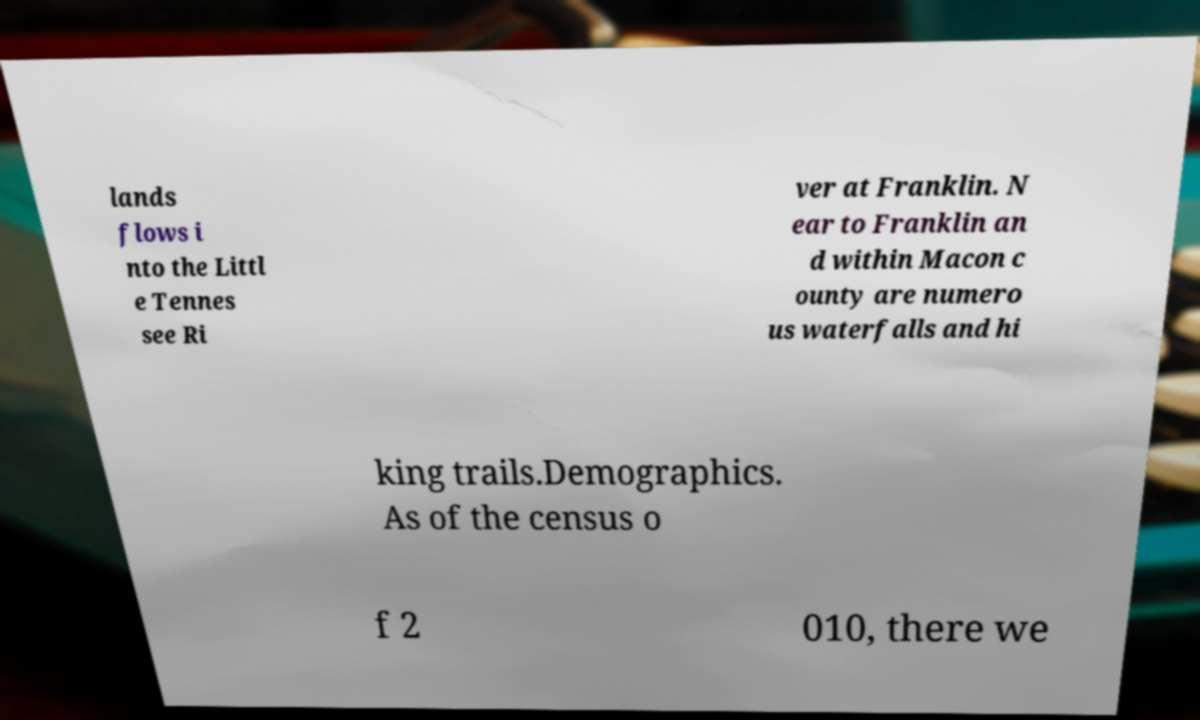Can you accurately transcribe the text from the provided image for me? lands flows i nto the Littl e Tennes see Ri ver at Franklin. N ear to Franklin an d within Macon c ounty are numero us waterfalls and hi king trails.Demographics. As of the census o f 2 010, there we 